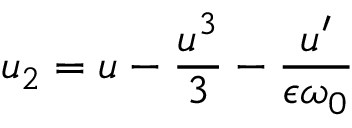Convert formula to latex. <formula><loc_0><loc_0><loc_500><loc_500>u _ { 2 } = u - \frac { u ^ { 3 } } { 3 } - \frac { u ^ { \prime } } { \epsilon \omega _ { 0 } }</formula> 